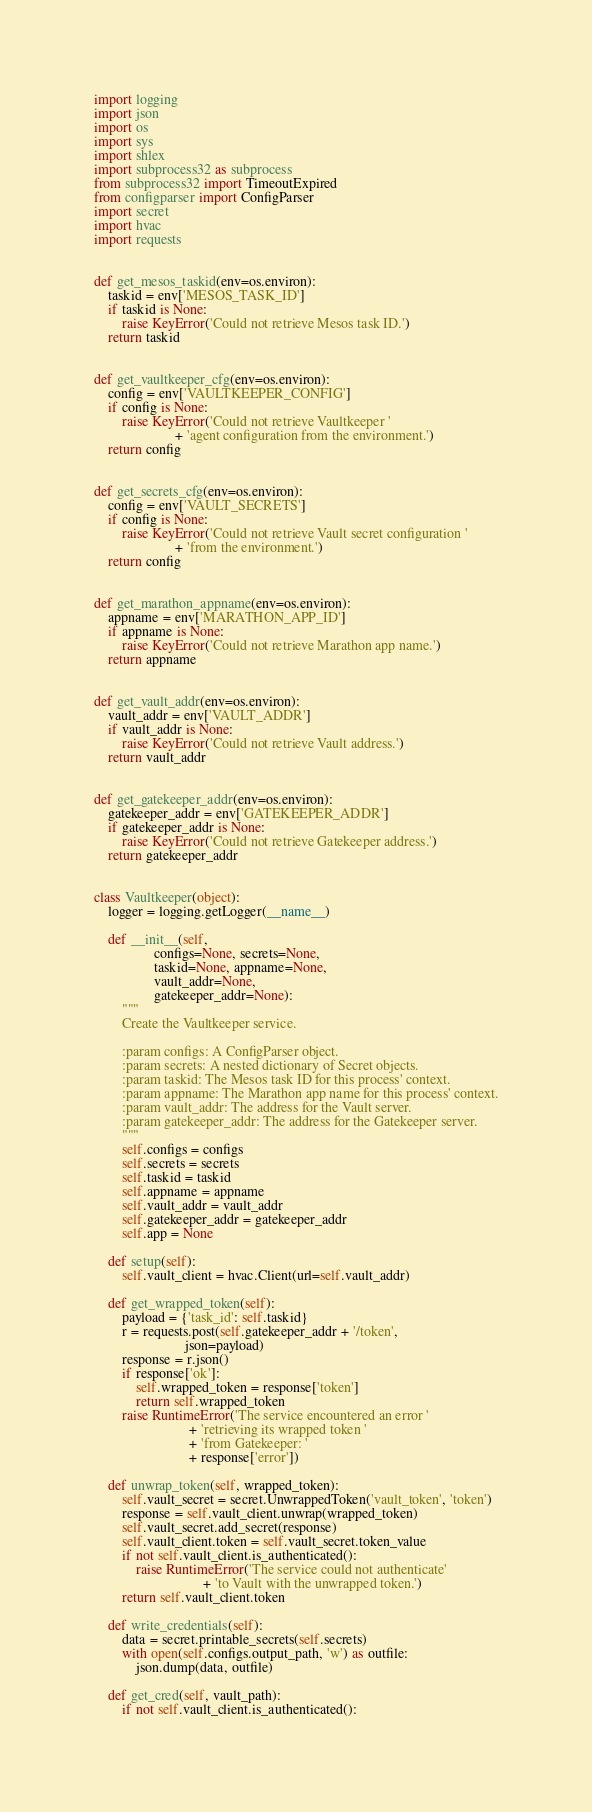Convert code to text. <code><loc_0><loc_0><loc_500><loc_500><_Python_>import logging
import json
import os
import sys
import shlex
import subprocess32 as subprocess
from subprocess32 import TimeoutExpired
from configparser import ConfigParser
import secret
import hvac
import requests


def get_mesos_taskid(env=os.environ):
    taskid = env['MESOS_TASK_ID']
    if taskid is None:
        raise KeyError('Could not retrieve Mesos task ID.')
    return taskid


def get_vaultkeeper_cfg(env=os.environ):
    config = env['VAULTKEEPER_CONFIG']
    if config is None:
        raise KeyError('Could not retrieve Vaultkeeper '
                       + 'agent configuration from the environment.')
    return config


def get_secrets_cfg(env=os.environ):
    config = env['VAULT_SECRETS']
    if config is None:
        raise KeyError('Could not retrieve Vault secret configuration '
                       + 'from the environment.')
    return config


def get_marathon_appname(env=os.environ):
    appname = env['MARATHON_APP_ID']
    if appname is None:
        raise KeyError('Could not retrieve Marathon app name.')
    return appname


def get_vault_addr(env=os.environ):
    vault_addr = env['VAULT_ADDR']
    if vault_addr is None:
        raise KeyError('Could not retrieve Vault address.')
    return vault_addr


def get_gatekeeper_addr(env=os.environ):
    gatekeeper_addr = env['GATEKEEPER_ADDR']
    if gatekeeper_addr is None:
        raise KeyError('Could not retrieve Gatekeeper address.')
    return gatekeeper_addr


class Vaultkeeper(object):
    logger = logging.getLogger(__name__)

    def __init__(self,
                 configs=None, secrets=None,
                 taskid=None, appname=None,
                 vault_addr=None,
                 gatekeeper_addr=None):
        """
        Create the Vaultkeeper service.

        :param configs: A ConfigParser object.
        :param secrets: A nested dictionary of Secret objects.
        :param taskid: The Mesos task ID for this process' context.
        :param appname: The Marathon app name for this process' context.
        :param vault_addr: The address for the Vault server.
        :param gatekeeper_addr: The address for the Gatekeeper server.
        """
        self.configs = configs
        self.secrets = secrets
        self.taskid = taskid
        self.appname = appname
        self.vault_addr = vault_addr
        self.gatekeeper_addr = gatekeeper_addr
        self.app = None

    def setup(self):
        self.vault_client = hvac.Client(url=self.vault_addr)

    def get_wrapped_token(self):
        payload = {'task_id': self.taskid}
        r = requests.post(self.gatekeeper_addr + '/token',
                          json=payload)
        response = r.json()
        if response['ok']:
            self.wrapped_token = response['token']
            return self.wrapped_token
        raise RuntimeError('The service encountered an error '
                           + 'retrieving its wrapped token '
                           + 'from Gatekeeper: '
                           + response['error'])

    def unwrap_token(self, wrapped_token):
        self.vault_secret = secret.UnwrappedToken('vault_token', 'token')
        response = self.vault_client.unwrap(wrapped_token)
        self.vault_secret.add_secret(response)
        self.vault_client.token = self.vault_secret.token_value
        if not self.vault_client.is_authenticated():
            raise RuntimeError('The service could not authenticate'
                               + 'to Vault with the unwrapped token.')
        return self.vault_client.token

    def write_credentials(self):
        data = secret.printable_secrets(self.secrets)
        with open(self.configs.output_path, 'w') as outfile:
            json.dump(data, outfile)

    def get_cred(self, vault_path):
        if not self.vault_client.is_authenticated():</code> 